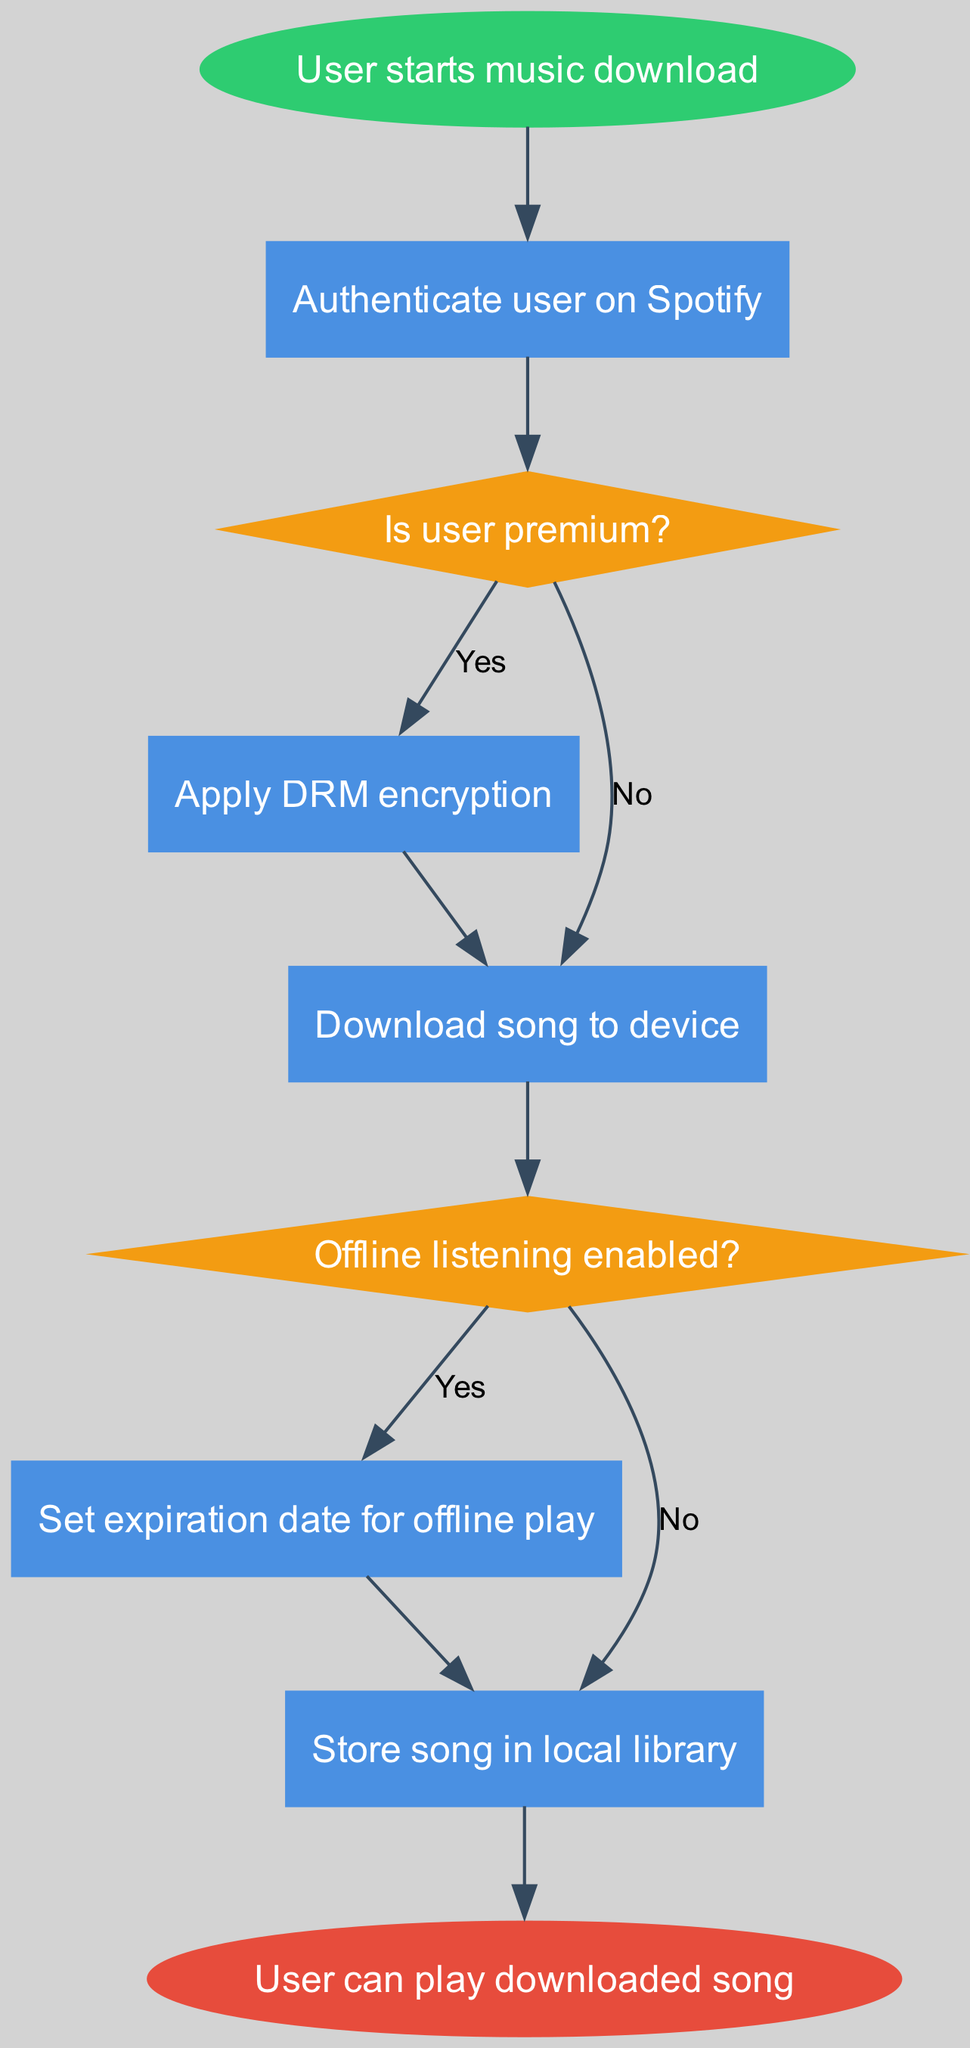What's the first step in the flowchart? The first step is indicated as "User starts music download," which is the starting node of the flowchart.
Answer: User starts music download How many decision nodes are in the diagram? The diagram contains two decision nodes: "Is user premium?" and "Offline listening enabled?"
Answer: 2 What happens if the user is not premium? If the user is not premium, the flowchart indicates that the next process is "Download song to device." This is directly connected to the decision node labeled "Is user premium?" with a label for the "No" path.
Answer: Download song to device What is set when offline listening is enabled? When offline listening is enabled, the flowchart shows that "Set expiration date for offline play" is performed as the next step following the decision node.
Answer: Set expiration date for offline play What is the last action taken in the process? The last action in the flowchart is "User can play downloaded song." This is indicated as the end point of the flowchart.
Answer: User can play downloaded song What connects the 'Apply DRM encryption' process to the 'Download song to device' process? The connection from 'Apply DRM encryption' to 'Download song to device' is a straight path indicating the next action that occurs after DRM encryption is applied.
Answer: Download song to device If offline listening is not enabled, what will the flowchart direct to? The flowchart directs to "Store song in local library" if offline listening is not enabled, as indicated by the label "No" from the decision node.
Answer: Store song in local library 